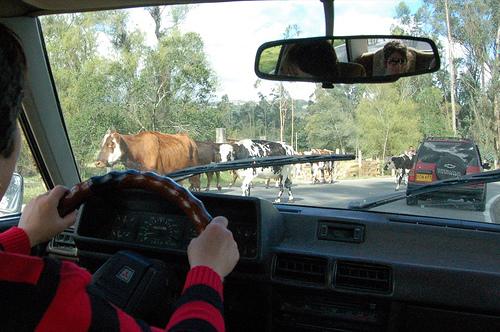What brand of vehicle is this?
Answer briefly. Mitsubishi. Are the cattle hindering traffic?
Write a very short answer. Yes. What type of shirt is the driver wearing?
Short answer required. Sweater. 